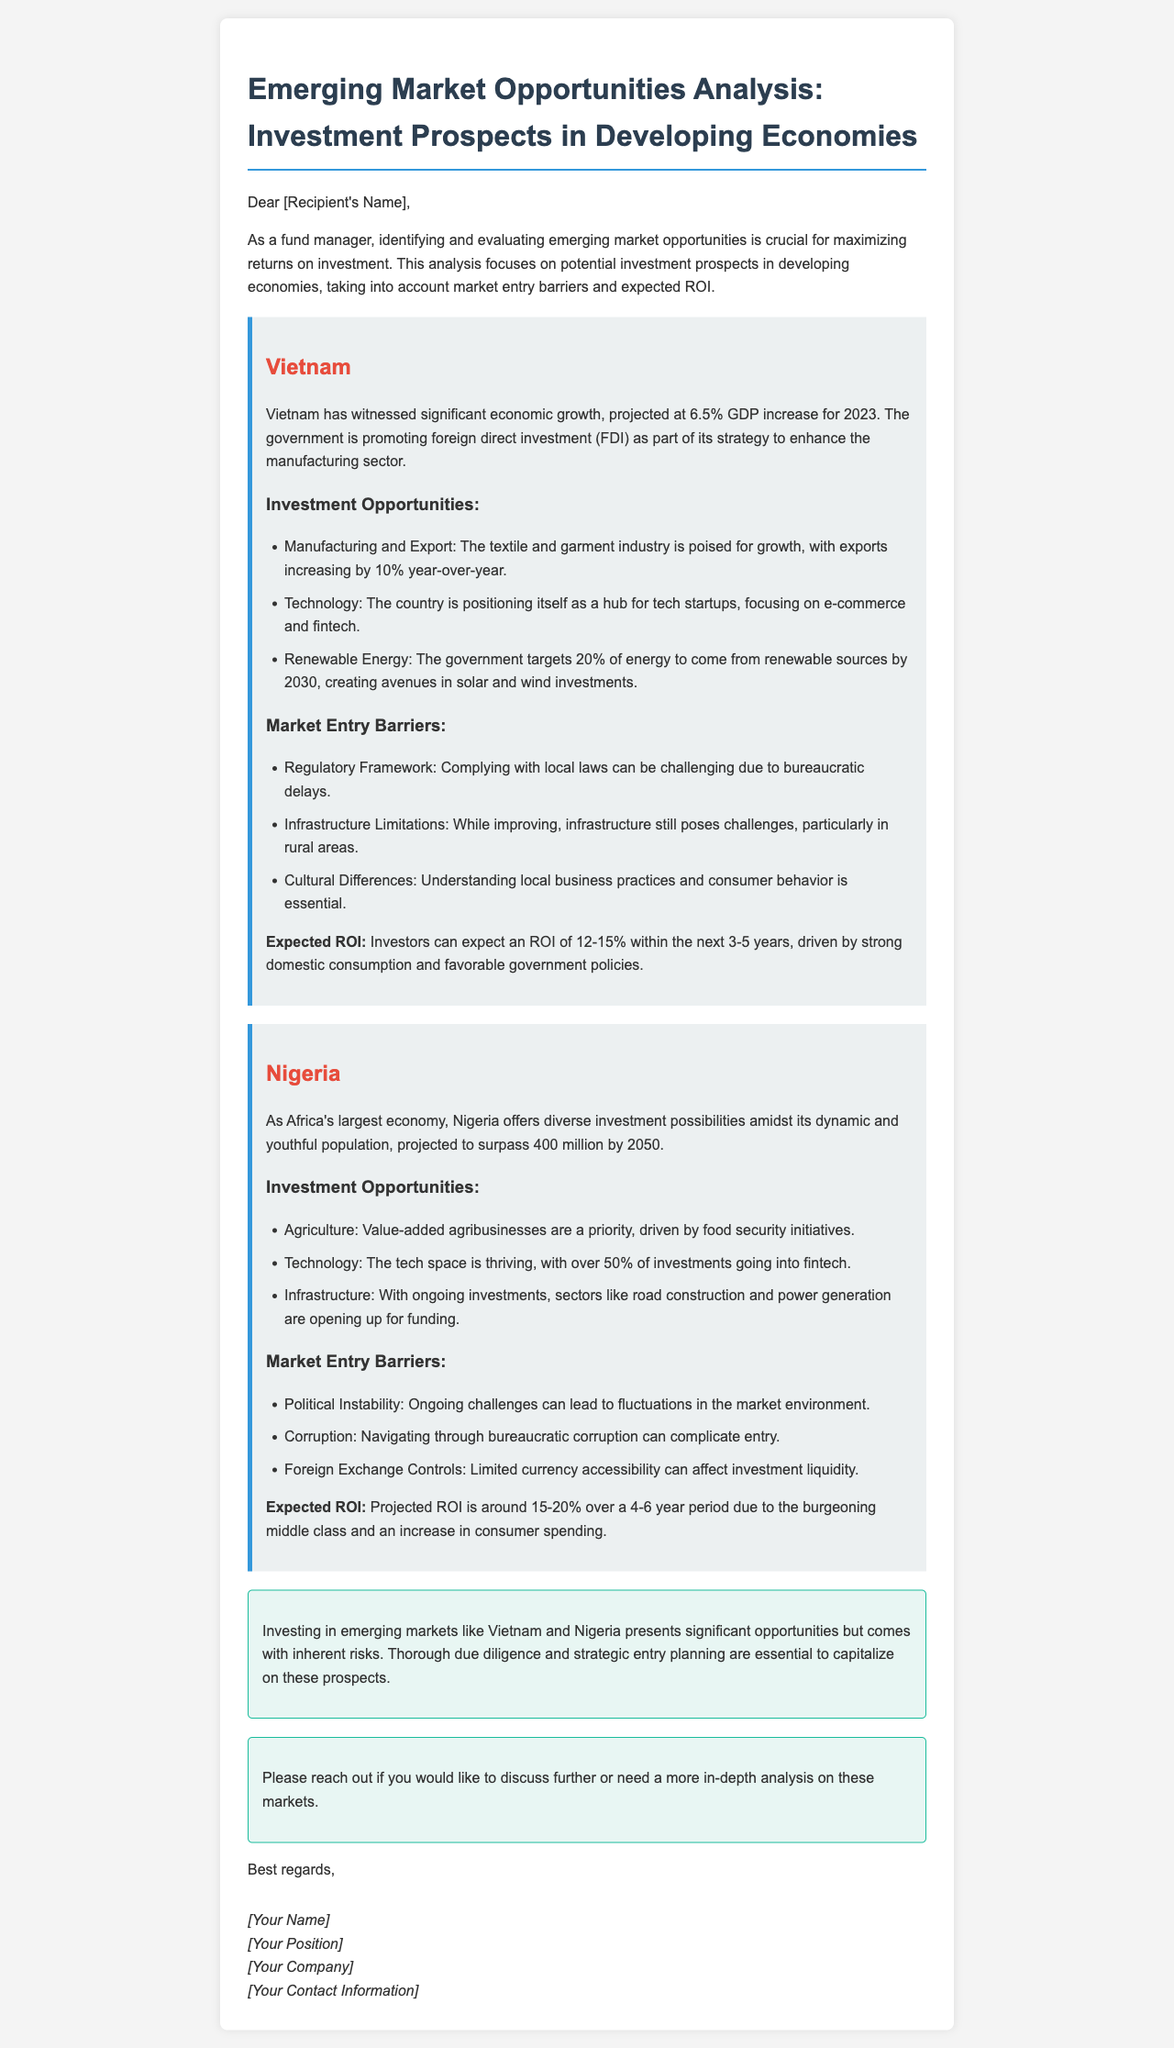What is the projected GDP increase for Vietnam in 2023? The document states that Vietnam has a projected GDP increase of 6.5% for 2023.
Answer: 6.5% What is the expected ROI for Vietnam investments? The expected ROI for Vietnam investments is mentioned to be 12-15% within the next 3-5 years.
Answer: 12-15% What are two investment opportunities in Nigeria? The document lists agriculture and technology as two investment opportunities in Nigeria.
Answer: Agriculture, Technology What is a key market entry barrier in Nigeria? The document highlights political instability as a significant market entry barrier in Nigeria.
Answer: Political Instability What percentage of energy does Vietnam aim to come from renewable sources by 2030? The document states that Vietnam targets 20% of energy to come from renewable sources by 2030.
Answer: 20% What is the projected ROI for Nigeria investments? The document indicates that the projected ROI for Nigeria investments is around 15-20% over a 4-6 year period.
Answer: 15-20% What is a challenge faced when entering the Vietnamese market? The document mentions that complying with local laws can be challenging due to bureaucratic delays as a challenge in Vietnam.
Answer: Bureaucratic delays What industries are highlighted for investment in Vietnam? The document mentions manufacturing, technology, and renewable energy as highlighted industries for investment in Vietnam.
Answer: Manufacturing, Technology, Renewable Energy What does the conclusion emphasize about investing in emerging markets? The conclusion emphasizes the need for thorough due diligence and strategic entry planning when investing in emerging markets.
Answer: Due diligence and strategic entry planning 